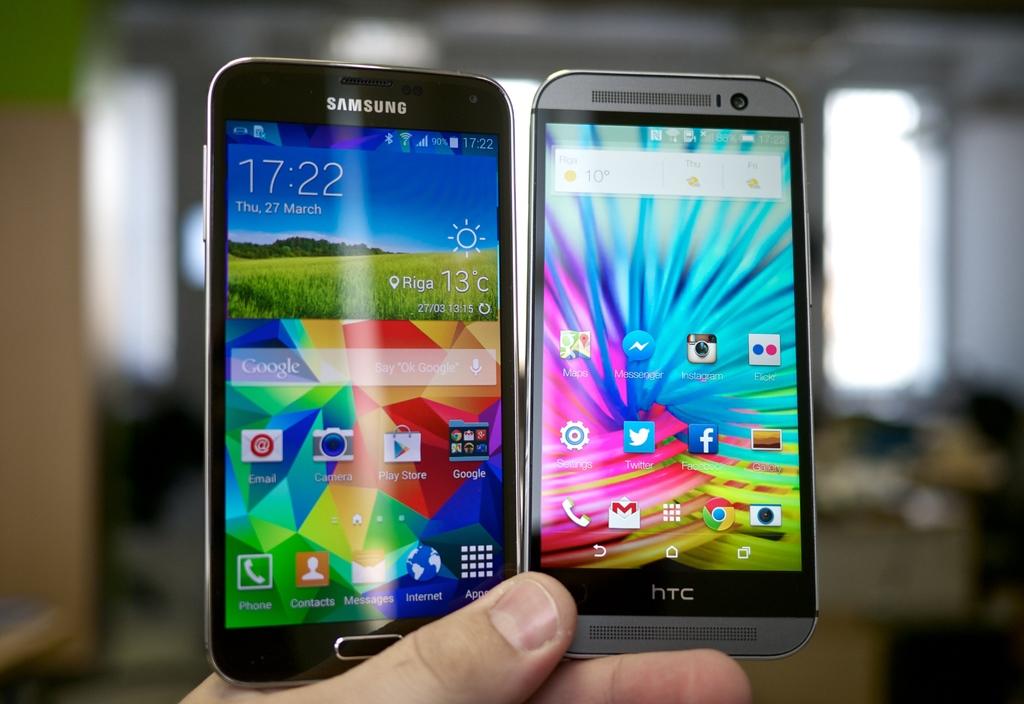What is the time?
Your response must be concise. 17:22. What brand of phone is on the left?
Offer a terse response. Samsung. 